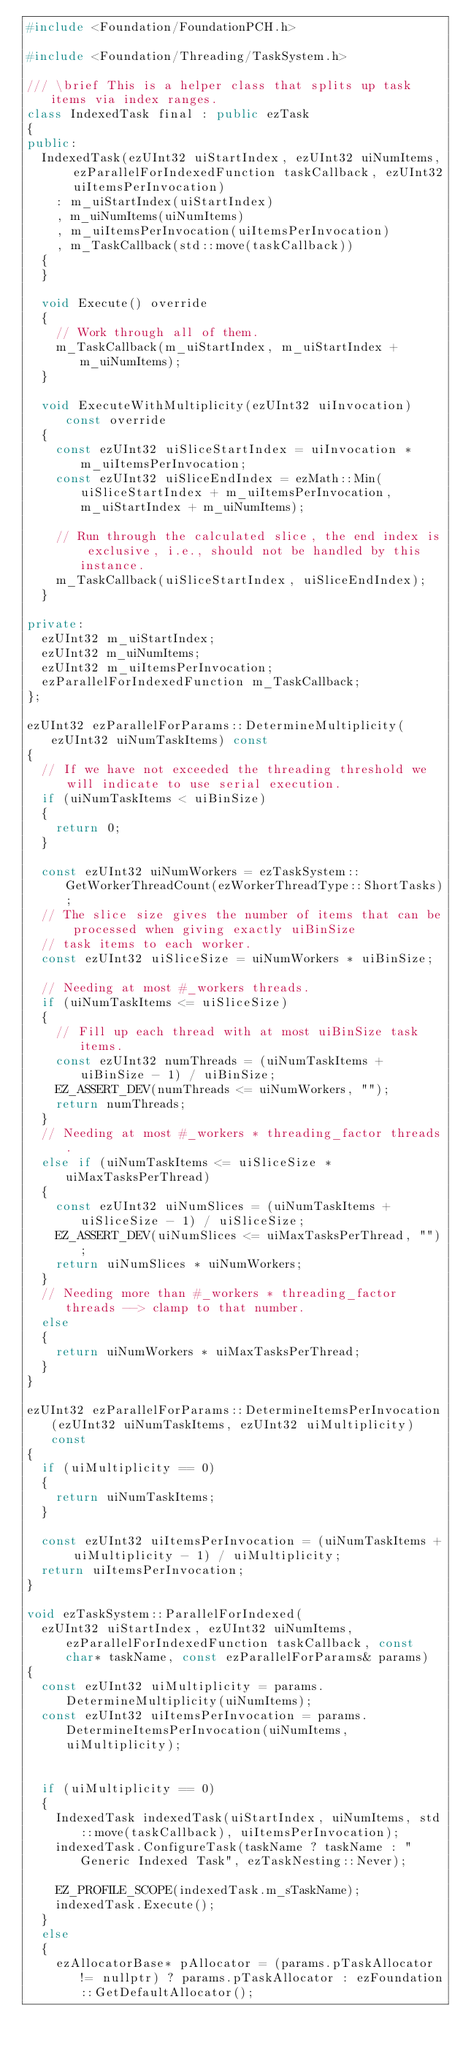<code> <loc_0><loc_0><loc_500><loc_500><_C++_>#include <Foundation/FoundationPCH.h>

#include <Foundation/Threading/TaskSystem.h>

/// \brief This is a helper class that splits up task items via index ranges.
class IndexedTask final : public ezTask
{
public:
  IndexedTask(ezUInt32 uiStartIndex, ezUInt32 uiNumItems, ezParallelForIndexedFunction taskCallback, ezUInt32 uiItemsPerInvocation)
    : m_uiStartIndex(uiStartIndex)
    , m_uiNumItems(uiNumItems)
    , m_uiItemsPerInvocation(uiItemsPerInvocation)
    , m_TaskCallback(std::move(taskCallback))
  {
  }

  void Execute() override
  {
    // Work through all of them.
    m_TaskCallback(m_uiStartIndex, m_uiStartIndex + m_uiNumItems);
  }

  void ExecuteWithMultiplicity(ezUInt32 uiInvocation) const override
  {
    const ezUInt32 uiSliceStartIndex = uiInvocation * m_uiItemsPerInvocation;
    const ezUInt32 uiSliceEndIndex = ezMath::Min(uiSliceStartIndex + m_uiItemsPerInvocation, m_uiStartIndex + m_uiNumItems);

    // Run through the calculated slice, the end index is exclusive, i.e., should not be handled by this instance.
    m_TaskCallback(uiSliceStartIndex, uiSliceEndIndex);
  }

private:
  ezUInt32 m_uiStartIndex;
  ezUInt32 m_uiNumItems;
  ezUInt32 m_uiItemsPerInvocation;
  ezParallelForIndexedFunction m_TaskCallback;
};

ezUInt32 ezParallelForParams::DetermineMultiplicity(ezUInt32 uiNumTaskItems) const
{
  // If we have not exceeded the threading threshold we will indicate to use serial execution.
  if (uiNumTaskItems < uiBinSize)
  {
    return 0;
  }

  const ezUInt32 uiNumWorkers = ezTaskSystem::GetWorkerThreadCount(ezWorkerThreadType::ShortTasks);
  // The slice size gives the number of items that can be processed when giving exactly uiBinSize
  // task items to each worker.
  const ezUInt32 uiSliceSize = uiNumWorkers * uiBinSize;

  // Needing at most #_workers threads.
  if (uiNumTaskItems <= uiSliceSize)
  {
    // Fill up each thread with at most uiBinSize task items.
    const ezUInt32 numThreads = (uiNumTaskItems + uiBinSize - 1) / uiBinSize;
    EZ_ASSERT_DEV(numThreads <= uiNumWorkers, "");
    return numThreads;
  }
  // Needing at most #_workers * threading_factor threads.
  else if (uiNumTaskItems <= uiSliceSize * uiMaxTasksPerThread)
  {
    const ezUInt32 uiNumSlices = (uiNumTaskItems + uiSliceSize - 1) / uiSliceSize;
    EZ_ASSERT_DEV(uiNumSlices <= uiMaxTasksPerThread, "");
    return uiNumSlices * uiNumWorkers;
  }
  // Needing more than #_workers * threading_factor threads --> clamp to that number.
  else
  {
    return uiNumWorkers * uiMaxTasksPerThread;
  }
}

ezUInt32 ezParallelForParams::DetermineItemsPerInvocation(ezUInt32 uiNumTaskItems, ezUInt32 uiMultiplicity) const
{
  if (uiMultiplicity == 0)
  {
    return uiNumTaskItems;
  }

  const ezUInt32 uiItemsPerInvocation = (uiNumTaskItems + uiMultiplicity - 1) / uiMultiplicity;
  return uiItemsPerInvocation;
}

void ezTaskSystem::ParallelForIndexed(
  ezUInt32 uiStartIndex, ezUInt32 uiNumItems, ezParallelForIndexedFunction taskCallback, const char* taskName, const ezParallelForParams& params)
{
  const ezUInt32 uiMultiplicity = params.DetermineMultiplicity(uiNumItems);
  const ezUInt32 uiItemsPerInvocation = params.DetermineItemsPerInvocation(uiNumItems, uiMultiplicity);


  if (uiMultiplicity == 0)
  {
    IndexedTask indexedTask(uiStartIndex, uiNumItems, std::move(taskCallback), uiItemsPerInvocation);
    indexedTask.ConfigureTask(taskName ? taskName : "Generic Indexed Task", ezTaskNesting::Never);

    EZ_PROFILE_SCOPE(indexedTask.m_sTaskName);
    indexedTask.Execute();
  }
  else
  {
    ezAllocatorBase* pAllocator = (params.pTaskAllocator != nullptr) ? params.pTaskAllocator : ezFoundation::GetDefaultAllocator();
</code> 